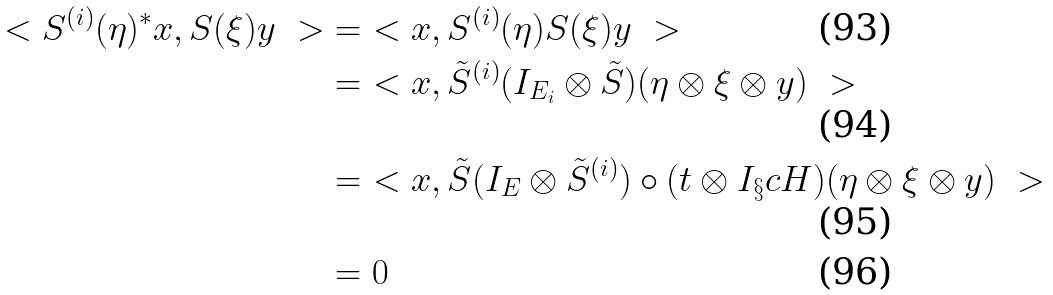<formula> <loc_0><loc_0><loc_500><loc_500>\ < S ^ { ( i ) } ( \eta ) ^ { * } x , S ( \xi ) y \ > & = \ < x , S ^ { ( i ) } ( \eta ) S ( \xi ) y \ > \\ & = \ < x , \tilde { S } ^ { ( i ) } ( I _ { E _ { i } } \otimes \tilde { S } ) ( \eta \otimes \xi \otimes y ) \ > \\ & = \ < x , \tilde { S } ( I _ { E } \otimes \tilde { S } ^ { ( i ) } ) \circ ( t \otimes I _ { \S } c { H } ) ( \eta \otimes \xi \otimes y ) \ > \\ & = 0</formula> 